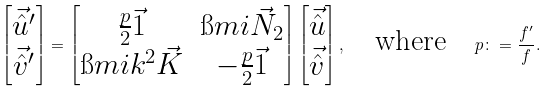Convert formula to latex. <formula><loc_0><loc_0><loc_500><loc_500>\begin{bmatrix} \vec { \hat { u } } ^ { \prime } \\ \vec { \hat { v } } ^ { \prime } \end{bmatrix} = \begin{bmatrix} \frac { p } { 2 } \vec { 1 } & \i m i \vec { N } _ { 2 } \\ \i m i k ^ { 2 } \vec { K } & - \frac { p } { 2 } \vec { 1 } \end{bmatrix} \begin{bmatrix} \vec { \hat { u } } \\ \vec { \hat { v } } \end{bmatrix} , \quad \text {where} \quad p \colon = \frac { f ^ { \prime } } { f } .</formula> 